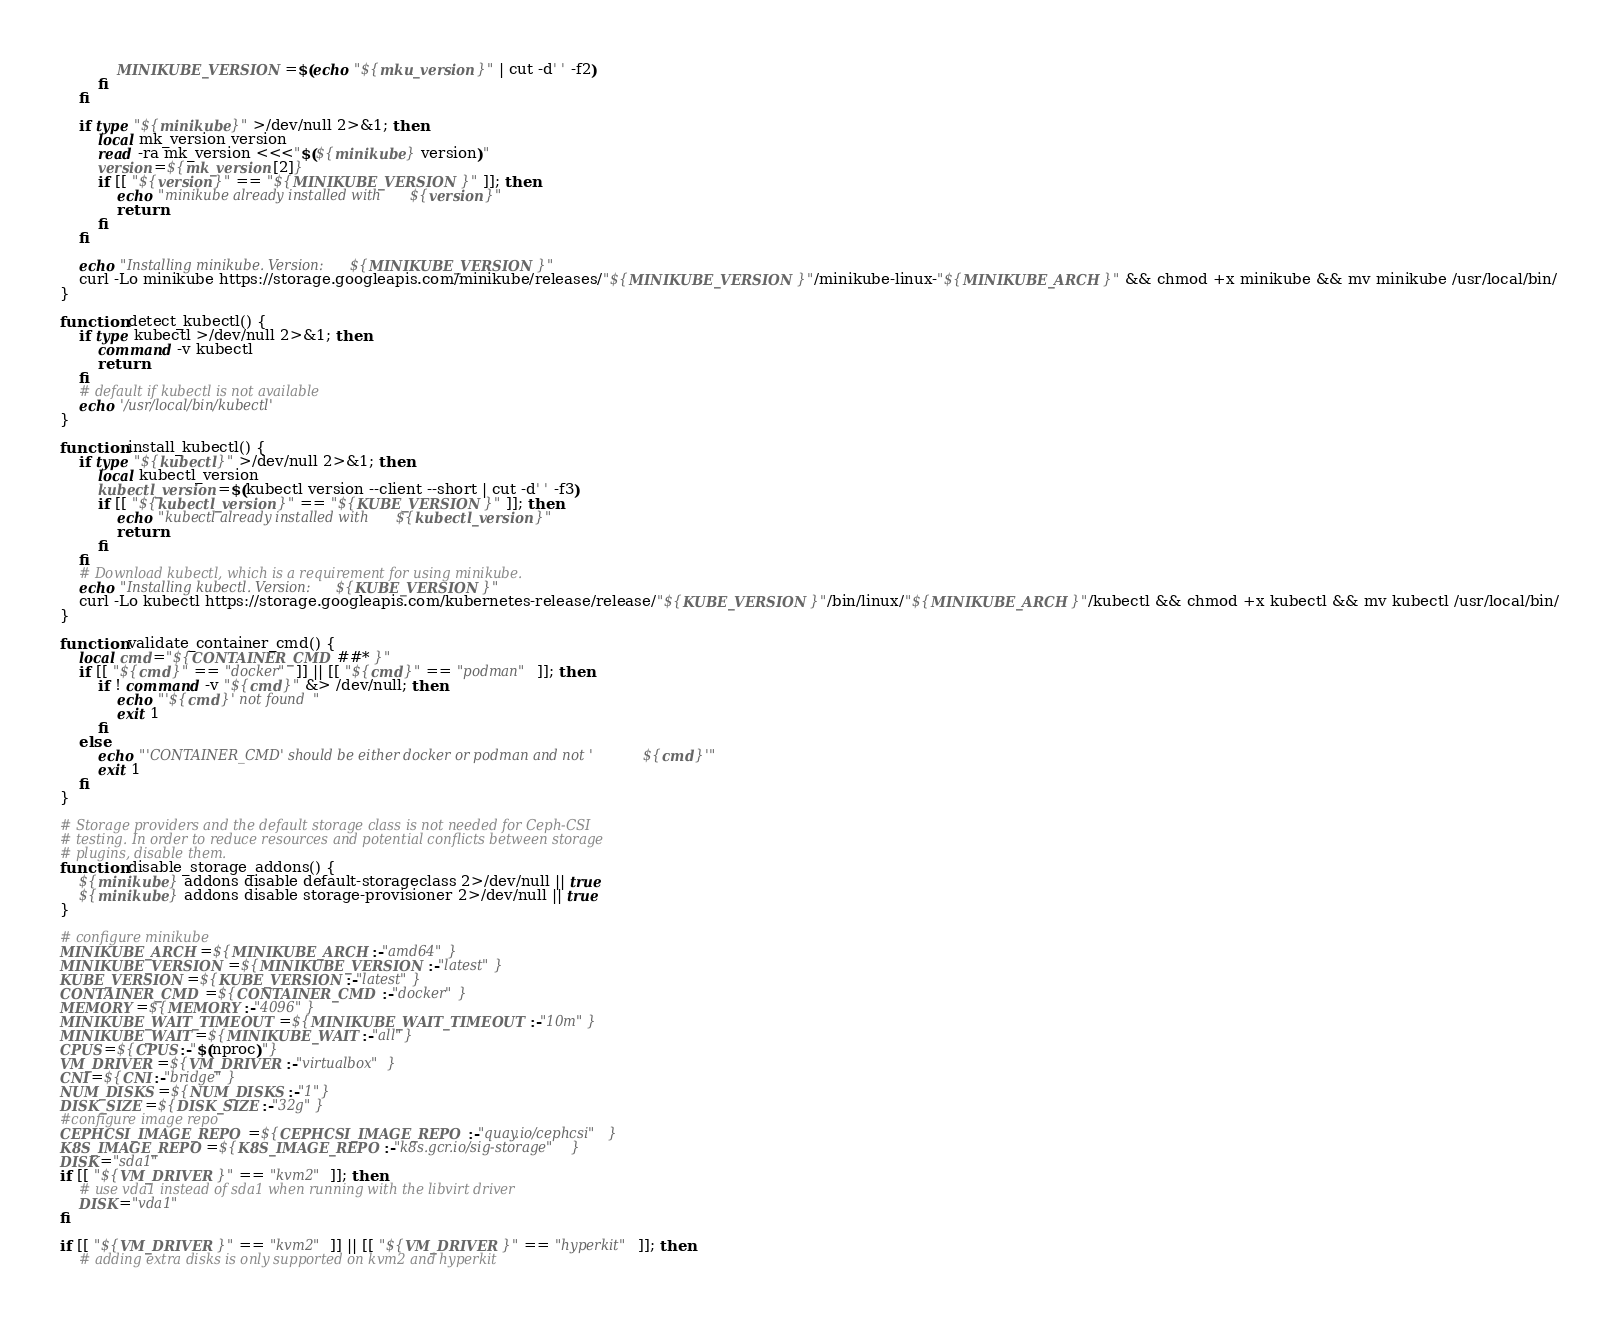<code> <loc_0><loc_0><loc_500><loc_500><_Bash_>            MINIKUBE_VERSION=$(echo "${mku_version}" | cut -d' ' -f2)
        fi
    fi

    if type "${minikube}" >/dev/null 2>&1; then
        local mk_version version
        read -ra mk_version <<<"$(${minikube} version)"
        version=${mk_version[2]}
        if [[ "${version}" == "${MINIKUBE_VERSION}" ]]; then
            echo "minikube already installed with ${version}"
            return
        fi
    fi

    echo "Installing minikube. Version: ${MINIKUBE_VERSION}"
    curl -Lo minikube https://storage.googleapis.com/minikube/releases/"${MINIKUBE_VERSION}"/minikube-linux-"${MINIKUBE_ARCH}" && chmod +x minikube && mv minikube /usr/local/bin/
}

function detect_kubectl() {
    if type kubectl >/dev/null 2>&1; then
        command -v kubectl
        return
    fi
    # default if kubectl is not available
    echo '/usr/local/bin/kubectl'
}

function install_kubectl() {
    if type "${kubectl}" >/dev/null 2>&1; then
        local kubectl_version
        kubectl_version=$(kubectl version --client --short | cut -d' ' -f3)
        if [[ "${kubectl_version}" == "${KUBE_VERSION}" ]]; then
            echo "kubectl already installed with ${kubectl_version}"
            return
        fi
    fi
    # Download kubectl, which is a requirement for using minikube.
    echo "Installing kubectl. Version: ${KUBE_VERSION}"
    curl -Lo kubectl https://storage.googleapis.com/kubernetes-release/release/"${KUBE_VERSION}"/bin/linux/"${MINIKUBE_ARCH}"/kubectl && chmod +x kubectl && mv kubectl /usr/local/bin/
}

function validate_container_cmd() {
    local cmd="${CONTAINER_CMD##* }"
    if [[ "${cmd}" == "docker" ]] || [[ "${cmd}" == "podman" ]]; then
        if ! command -v "${cmd}" &> /dev/null; then
            echo "'${cmd}' not found"
            exit 1
        fi
    else
        echo "'CONTAINER_CMD' should be either docker or podman and not '${cmd}'"
        exit 1
    fi
}

# Storage providers and the default storage class is not needed for Ceph-CSI
# testing. In order to reduce resources and potential conflicts between storage
# plugins, disable them.
function disable_storage_addons() {
    ${minikube} addons disable default-storageclass 2>/dev/null || true
    ${minikube} addons disable storage-provisioner 2>/dev/null || true
}

# configure minikube
MINIKUBE_ARCH=${MINIKUBE_ARCH:-"amd64"}
MINIKUBE_VERSION=${MINIKUBE_VERSION:-"latest"}
KUBE_VERSION=${KUBE_VERSION:-"latest"}
CONTAINER_CMD=${CONTAINER_CMD:-"docker"}
MEMORY=${MEMORY:-"4096"}
MINIKUBE_WAIT_TIMEOUT=${MINIKUBE_WAIT_TIMEOUT:-"10m"}
MINIKUBE_WAIT=${MINIKUBE_WAIT:-"all"}
CPUS=${CPUS:-"$(nproc)"}
VM_DRIVER=${VM_DRIVER:-"virtualbox"}
CNI=${CNI:-"bridge"}
NUM_DISKS=${NUM_DISKS:-"1"}
DISK_SIZE=${DISK_SIZE:-"32g"}
#configure image repo
CEPHCSI_IMAGE_REPO=${CEPHCSI_IMAGE_REPO:-"quay.io/cephcsi"}
K8S_IMAGE_REPO=${K8S_IMAGE_REPO:-"k8s.gcr.io/sig-storage"}
DISK="sda1"
if [[ "${VM_DRIVER}" == "kvm2" ]]; then
    # use vda1 instead of sda1 when running with the libvirt driver
    DISK="vda1"
fi

if [[ "${VM_DRIVER}" == "kvm2" ]] || [[ "${VM_DRIVER}" == "hyperkit" ]]; then
    # adding extra disks is only supported on kvm2 and hyperkit</code> 